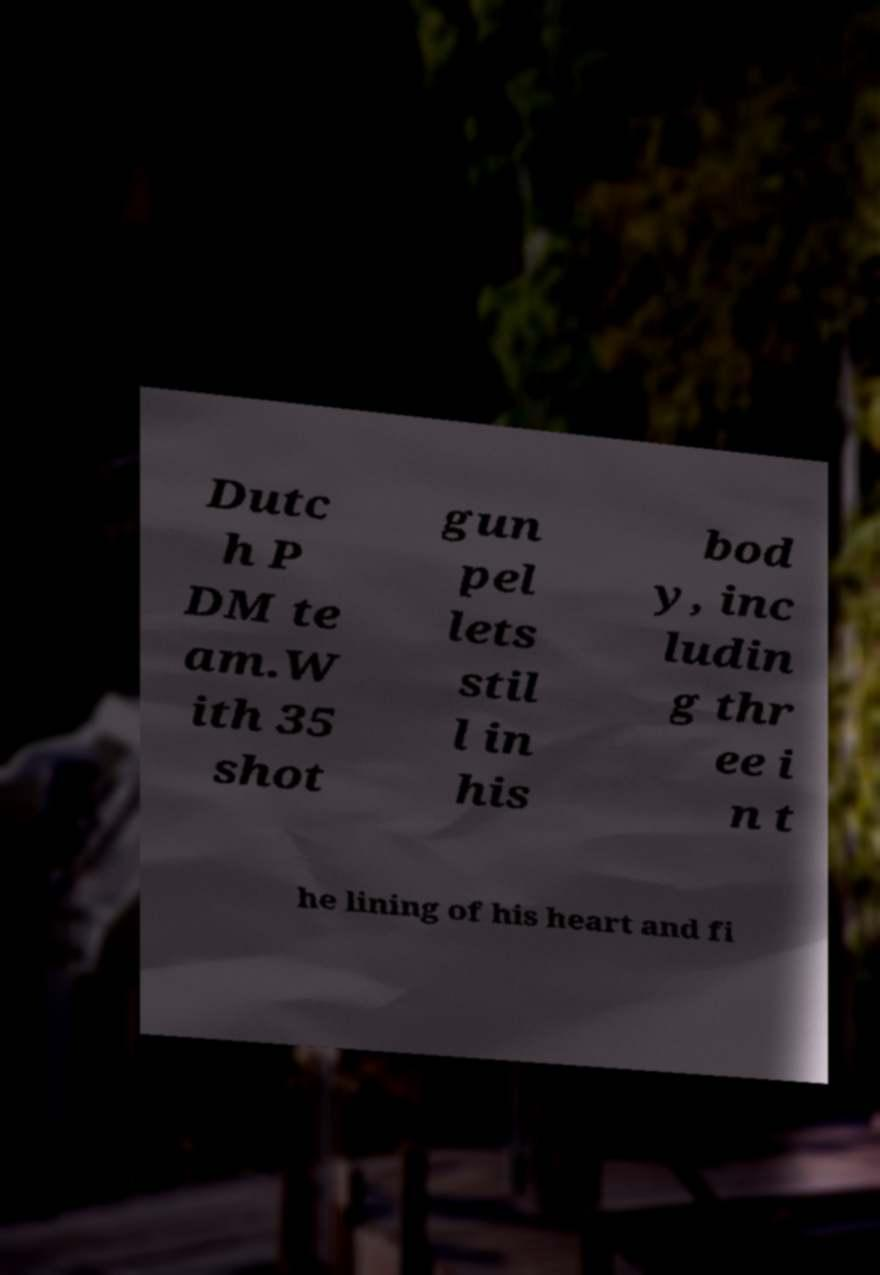There's text embedded in this image that I need extracted. Can you transcribe it verbatim? Dutc h P DM te am.W ith 35 shot gun pel lets stil l in his bod y, inc ludin g thr ee i n t he lining of his heart and fi 